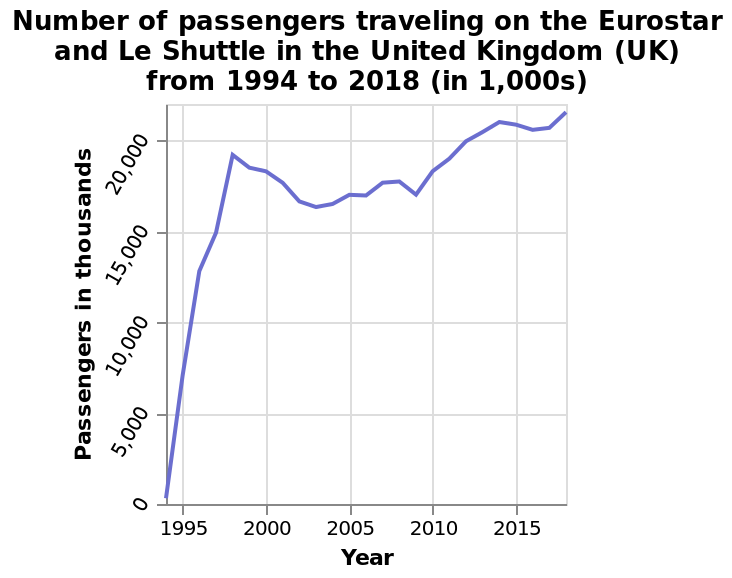<image>
What is the range of the y-axis on the line plot? The range of the y-axis on the line plot is 0 to 20,000. Describe the following image in detail Number of passengers traveling on the Eurostar and Le Shuttle in the United Kingdom (UK) from 1994 to 2018 (in 1,000s) is a line plot. There is a linear scale of range 0 to 20,000 along the y-axis, marked Passengers in thousands. There is a linear scale with a minimum of 1995 and a maximum of 2015 along the x-axis, labeled Year.  How did the number of passengers change from 1994 to 1998?  The number of passengers increased sharply from zero to nearly 19,000 from 1994 to 1998. 